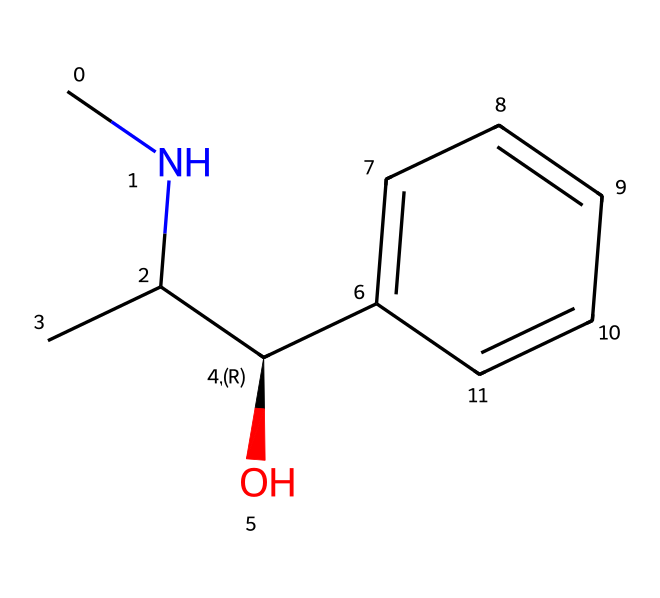What is the molecular formula of ephedrine? By analyzing the SMILES representation, we can count the number of each type of atom in the structure. The breakdown shows 9 carbon atoms, 13 hydrogen atoms, and 1 nitrogen atom, leading to the molecular formula C9H13N.
Answer: C9H13N How many rings are present in the ephedrine structure? Upon examining the SMILES notation, we note that there are no ring structures indicated (no parentheses suggesting cyclic connections), meaning the structure is linear without any rings.
Answer: 0 What functional groups are present in ephedrine? The structure contains a hydroxyl group (-OH) attached to a carbon and an amine group (-NH) linked to another carbon, indicating the presence of both of these functional groups in the ephedrine molecule.
Answer: hydroxyl, amine What type of stereochemistry is present in this molecule? The presence of "C@H" in the SMILES indicates that there is a chiral center at that carbon atom, meaning the molecule has one stereogenic center and can exist in two enantiomeric forms.
Answer: chiral What is the main pharmacological effect attributed to ephedrine? Ephedrine is primarily known for its stimulant effects, including increasing heart rate and energy levels, contributing to its use in weight loss and energy-boosting applications.
Answer: stimulant What structural feature differentiates alkaloids like ephedrine from other organic compounds? The key distinguishing feature of alkaloids is the presence of a basic nitrogen atom within a heterocyclic structure or in this case as part of a carbon chain, which contributes to their biological activity and effects.
Answer: nitrogen atom 